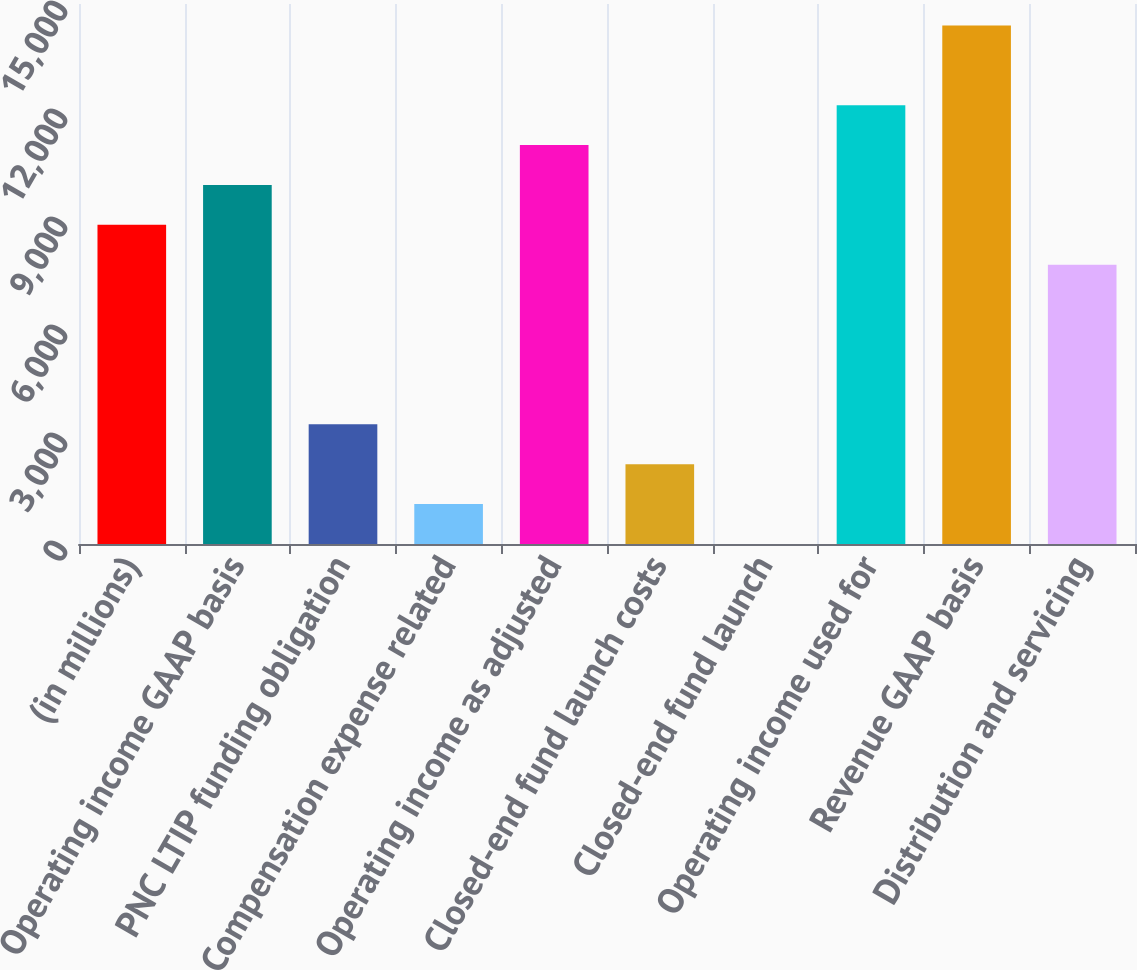<chart> <loc_0><loc_0><loc_500><loc_500><bar_chart><fcel>(in millions)<fcel>Operating income GAAP basis<fcel>PNC LTIP funding obligation<fcel>Compensation expense related<fcel>Operating income as adjusted<fcel>Closed-end fund launch costs<fcel>Closed-end fund launch<fcel>Operating income used for<fcel>Revenue GAAP basis<fcel>Distribution and servicing<nl><fcel>8865<fcel>9973<fcel>3325<fcel>1109<fcel>11081<fcel>2217<fcel>1<fcel>12189<fcel>14405<fcel>7757<nl></chart> 